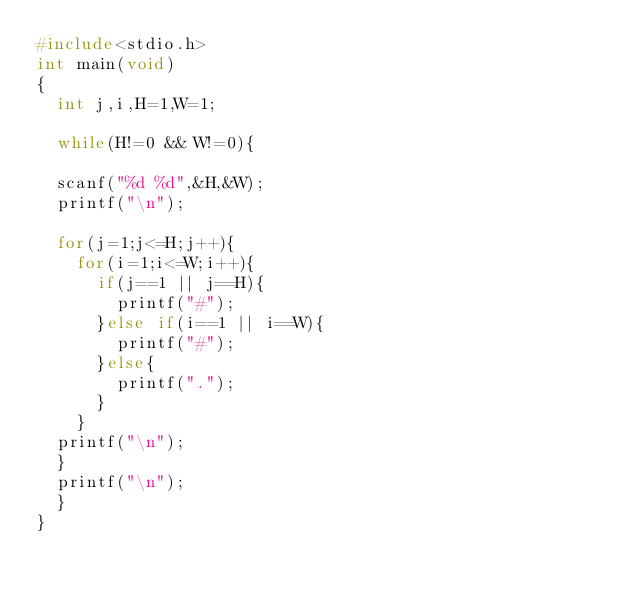<code> <loc_0><loc_0><loc_500><loc_500><_C_>#include<stdio.h>
int main(void)
{
	int j,i,H=1,W=1;

	while(H!=0 && W!=0){
	
	scanf("%d %d",&H,&W);
	printf("\n");

	for(j=1;j<=H;j++){
		for(i=1;i<=W;i++){
			if(j==1 || j==H){
				printf("#");
			}else if(i==1 || i==W){
				printf("#");
			}else{
				printf(".");
			}
		}
	printf("\n");
	}
	printf("\n");
	}
}
</code> 